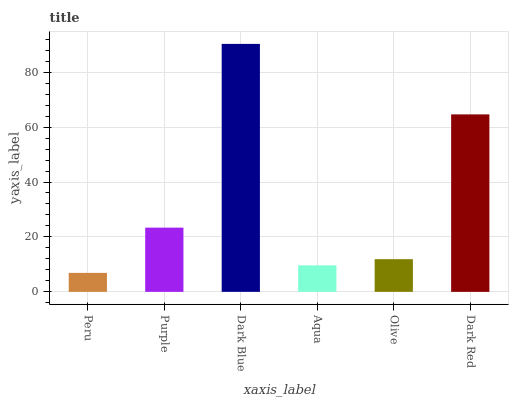Is Peru the minimum?
Answer yes or no. Yes. Is Dark Blue the maximum?
Answer yes or no. Yes. Is Purple the minimum?
Answer yes or no. No. Is Purple the maximum?
Answer yes or no. No. Is Purple greater than Peru?
Answer yes or no. Yes. Is Peru less than Purple?
Answer yes or no. Yes. Is Peru greater than Purple?
Answer yes or no. No. Is Purple less than Peru?
Answer yes or no. No. Is Purple the high median?
Answer yes or no. Yes. Is Olive the low median?
Answer yes or no. Yes. Is Aqua the high median?
Answer yes or no. No. Is Purple the low median?
Answer yes or no. No. 